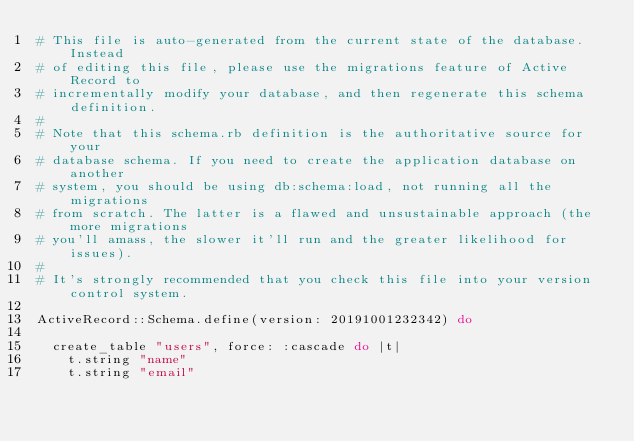Convert code to text. <code><loc_0><loc_0><loc_500><loc_500><_Ruby_># This file is auto-generated from the current state of the database. Instead
# of editing this file, please use the migrations feature of Active Record to
# incrementally modify your database, and then regenerate this schema definition.
#
# Note that this schema.rb definition is the authoritative source for your
# database schema. If you need to create the application database on another
# system, you should be using db:schema:load, not running all the migrations
# from scratch. The latter is a flawed and unsustainable approach (the more migrations
# you'll amass, the slower it'll run and the greater likelihood for issues).
#
# It's strongly recommended that you check this file into your version control system.

ActiveRecord::Schema.define(version: 20191001232342) do

  create_table "users", force: :cascade do |t|
    t.string "name"
    t.string "email"</code> 